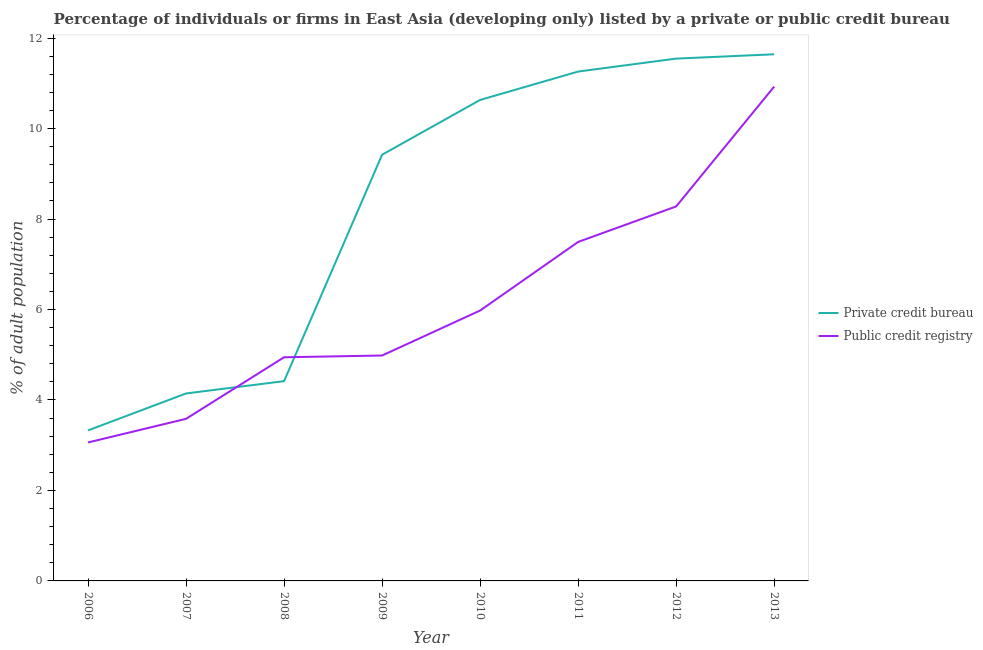Is the number of lines equal to the number of legend labels?
Offer a terse response. Yes. What is the percentage of firms listed by private credit bureau in 2011?
Provide a succinct answer. 11.26. Across all years, what is the maximum percentage of firms listed by public credit bureau?
Your response must be concise. 10.93. Across all years, what is the minimum percentage of firms listed by private credit bureau?
Keep it short and to the point. 3.33. In which year was the percentage of firms listed by private credit bureau minimum?
Your answer should be compact. 2006. What is the total percentage of firms listed by public credit bureau in the graph?
Keep it short and to the point. 49.25. What is the difference between the percentage of firms listed by public credit bureau in 2007 and that in 2008?
Ensure brevity in your answer.  -1.36. What is the difference between the percentage of firms listed by public credit bureau in 2013 and the percentage of firms listed by private credit bureau in 2008?
Keep it short and to the point. 6.51. What is the average percentage of firms listed by private credit bureau per year?
Give a very brief answer. 8.3. In the year 2012, what is the difference between the percentage of firms listed by private credit bureau and percentage of firms listed by public credit bureau?
Your answer should be very brief. 3.27. What is the ratio of the percentage of firms listed by public credit bureau in 2008 to that in 2010?
Give a very brief answer. 0.83. Is the difference between the percentage of firms listed by private credit bureau in 2010 and 2012 greater than the difference between the percentage of firms listed by public credit bureau in 2010 and 2012?
Your response must be concise. Yes. What is the difference between the highest and the second highest percentage of firms listed by public credit bureau?
Make the answer very short. 2.65. What is the difference between the highest and the lowest percentage of firms listed by private credit bureau?
Offer a terse response. 8.32. In how many years, is the percentage of firms listed by private credit bureau greater than the average percentage of firms listed by private credit bureau taken over all years?
Make the answer very short. 5. Does the percentage of firms listed by private credit bureau monotonically increase over the years?
Provide a short and direct response. Yes. Is the percentage of firms listed by public credit bureau strictly greater than the percentage of firms listed by private credit bureau over the years?
Provide a short and direct response. No. Is the percentage of firms listed by public credit bureau strictly less than the percentage of firms listed by private credit bureau over the years?
Ensure brevity in your answer.  No. How many years are there in the graph?
Your answer should be compact. 8. What is the difference between two consecutive major ticks on the Y-axis?
Make the answer very short. 2. Are the values on the major ticks of Y-axis written in scientific E-notation?
Provide a succinct answer. No. Does the graph contain any zero values?
Your answer should be compact. No. Does the graph contain grids?
Your response must be concise. No. How are the legend labels stacked?
Your response must be concise. Vertical. What is the title of the graph?
Keep it short and to the point. Percentage of individuals or firms in East Asia (developing only) listed by a private or public credit bureau. What is the label or title of the X-axis?
Offer a terse response. Year. What is the label or title of the Y-axis?
Your answer should be compact. % of adult population. What is the % of adult population in Private credit bureau in 2006?
Your answer should be very brief. 3.33. What is the % of adult population in Public credit registry in 2006?
Your answer should be compact. 3.06. What is the % of adult population in Private credit bureau in 2007?
Provide a short and direct response. 4.14. What is the % of adult population of Public credit registry in 2007?
Make the answer very short. 3.58. What is the % of adult population of Private credit bureau in 2008?
Your answer should be compact. 4.42. What is the % of adult population in Public credit registry in 2008?
Provide a short and direct response. 4.94. What is the % of adult population of Private credit bureau in 2009?
Your answer should be very brief. 9.42. What is the % of adult population in Public credit registry in 2009?
Keep it short and to the point. 4.98. What is the % of adult population of Private credit bureau in 2010?
Give a very brief answer. 10.63. What is the % of adult population of Public credit registry in 2010?
Give a very brief answer. 5.98. What is the % of adult population in Private credit bureau in 2011?
Your response must be concise. 11.26. What is the % of adult population of Public credit registry in 2011?
Your response must be concise. 7.49. What is the % of adult population of Private credit bureau in 2012?
Keep it short and to the point. 11.55. What is the % of adult population in Public credit registry in 2012?
Provide a succinct answer. 8.28. What is the % of adult population of Private credit bureau in 2013?
Ensure brevity in your answer.  11.64. What is the % of adult population in Public credit registry in 2013?
Keep it short and to the point. 10.93. Across all years, what is the maximum % of adult population of Private credit bureau?
Offer a terse response. 11.64. Across all years, what is the maximum % of adult population of Public credit registry?
Ensure brevity in your answer.  10.93. Across all years, what is the minimum % of adult population in Private credit bureau?
Make the answer very short. 3.33. Across all years, what is the minimum % of adult population of Public credit registry?
Ensure brevity in your answer.  3.06. What is the total % of adult population of Private credit bureau in the graph?
Your answer should be very brief. 66.4. What is the total % of adult population of Public credit registry in the graph?
Provide a succinct answer. 49.25. What is the difference between the % of adult population in Private credit bureau in 2006 and that in 2007?
Give a very brief answer. -0.82. What is the difference between the % of adult population of Public credit registry in 2006 and that in 2007?
Offer a very short reply. -0.52. What is the difference between the % of adult population in Private credit bureau in 2006 and that in 2008?
Provide a succinct answer. -1.09. What is the difference between the % of adult population in Public credit registry in 2006 and that in 2008?
Provide a succinct answer. -1.88. What is the difference between the % of adult population of Private credit bureau in 2006 and that in 2009?
Your answer should be very brief. -6.09. What is the difference between the % of adult population in Public credit registry in 2006 and that in 2009?
Your answer should be compact. -1.92. What is the difference between the % of adult population of Private credit bureau in 2006 and that in 2010?
Your response must be concise. -7.31. What is the difference between the % of adult population of Public credit registry in 2006 and that in 2010?
Provide a succinct answer. -2.92. What is the difference between the % of adult population in Private credit bureau in 2006 and that in 2011?
Give a very brief answer. -7.93. What is the difference between the % of adult population in Public credit registry in 2006 and that in 2011?
Make the answer very short. -4.43. What is the difference between the % of adult population in Private credit bureau in 2006 and that in 2012?
Your answer should be very brief. -8.22. What is the difference between the % of adult population in Public credit registry in 2006 and that in 2012?
Ensure brevity in your answer.  -5.22. What is the difference between the % of adult population of Private credit bureau in 2006 and that in 2013?
Your response must be concise. -8.32. What is the difference between the % of adult population of Public credit registry in 2006 and that in 2013?
Provide a succinct answer. -7.87. What is the difference between the % of adult population of Private credit bureau in 2007 and that in 2008?
Give a very brief answer. -0.27. What is the difference between the % of adult population of Public credit registry in 2007 and that in 2008?
Offer a very short reply. -1.36. What is the difference between the % of adult population in Private credit bureau in 2007 and that in 2009?
Offer a very short reply. -5.28. What is the difference between the % of adult population in Public credit registry in 2007 and that in 2009?
Give a very brief answer. -1.4. What is the difference between the % of adult population of Private credit bureau in 2007 and that in 2010?
Your answer should be very brief. -6.49. What is the difference between the % of adult population of Public credit registry in 2007 and that in 2010?
Provide a succinct answer. -2.39. What is the difference between the % of adult population of Private credit bureau in 2007 and that in 2011?
Your answer should be very brief. -7.12. What is the difference between the % of adult population in Public credit registry in 2007 and that in 2011?
Offer a terse response. -3.91. What is the difference between the % of adult population of Private credit bureau in 2007 and that in 2012?
Your response must be concise. -7.4. What is the difference between the % of adult population of Public credit registry in 2007 and that in 2012?
Ensure brevity in your answer.  -4.7. What is the difference between the % of adult population of Private credit bureau in 2007 and that in 2013?
Provide a succinct answer. -7.5. What is the difference between the % of adult population of Public credit registry in 2007 and that in 2013?
Your answer should be compact. -7.35. What is the difference between the % of adult population in Private credit bureau in 2008 and that in 2009?
Keep it short and to the point. -5.01. What is the difference between the % of adult population of Public credit registry in 2008 and that in 2009?
Your answer should be compact. -0.04. What is the difference between the % of adult population of Private credit bureau in 2008 and that in 2010?
Your response must be concise. -6.22. What is the difference between the % of adult population of Public credit registry in 2008 and that in 2010?
Keep it short and to the point. -1.03. What is the difference between the % of adult population in Private credit bureau in 2008 and that in 2011?
Make the answer very short. -6.84. What is the difference between the % of adult population of Public credit registry in 2008 and that in 2011?
Provide a succinct answer. -2.55. What is the difference between the % of adult population of Private credit bureau in 2008 and that in 2012?
Make the answer very short. -7.13. What is the difference between the % of adult population of Public credit registry in 2008 and that in 2012?
Give a very brief answer. -3.33. What is the difference between the % of adult population of Private credit bureau in 2008 and that in 2013?
Your answer should be very brief. -7.23. What is the difference between the % of adult population in Public credit registry in 2008 and that in 2013?
Keep it short and to the point. -5.98. What is the difference between the % of adult population of Private credit bureau in 2009 and that in 2010?
Provide a succinct answer. -1.21. What is the difference between the % of adult population of Public credit registry in 2009 and that in 2010?
Your answer should be very brief. -0.99. What is the difference between the % of adult population of Private credit bureau in 2009 and that in 2011?
Your response must be concise. -1.84. What is the difference between the % of adult population in Public credit registry in 2009 and that in 2011?
Provide a short and direct response. -2.51. What is the difference between the % of adult population of Private credit bureau in 2009 and that in 2012?
Offer a very short reply. -2.13. What is the difference between the % of adult population of Public credit registry in 2009 and that in 2012?
Keep it short and to the point. -3.3. What is the difference between the % of adult population of Private credit bureau in 2009 and that in 2013?
Ensure brevity in your answer.  -2.22. What is the difference between the % of adult population of Public credit registry in 2009 and that in 2013?
Your answer should be compact. -5.95. What is the difference between the % of adult population of Private credit bureau in 2010 and that in 2011?
Give a very brief answer. -0.63. What is the difference between the % of adult population in Public credit registry in 2010 and that in 2011?
Offer a very short reply. -1.52. What is the difference between the % of adult population in Private credit bureau in 2010 and that in 2012?
Ensure brevity in your answer.  -0.91. What is the difference between the % of adult population of Public credit registry in 2010 and that in 2012?
Offer a very short reply. -2.3. What is the difference between the % of adult population of Private credit bureau in 2010 and that in 2013?
Provide a short and direct response. -1.01. What is the difference between the % of adult population in Public credit registry in 2010 and that in 2013?
Give a very brief answer. -4.95. What is the difference between the % of adult population of Private credit bureau in 2011 and that in 2012?
Ensure brevity in your answer.  -0.29. What is the difference between the % of adult population of Public credit registry in 2011 and that in 2012?
Provide a short and direct response. -0.78. What is the difference between the % of adult population of Private credit bureau in 2011 and that in 2013?
Give a very brief answer. -0.38. What is the difference between the % of adult population in Public credit registry in 2011 and that in 2013?
Make the answer very short. -3.43. What is the difference between the % of adult population of Private credit bureau in 2012 and that in 2013?
Your answer should be very brief. -0.1. What is the difference between the % of adult population of Public credit registry in 2012 and that in 2013?
Keep it short and to the point. -2.65. What is the difference between the % of adult population of Private credit bureau in 2006 and the % of adult population of Public credit registry in 2007?
Make the answer very short. -0.26. What is the difference between the % of adult population in Private credit bureau in 2006 and the % of adult population in Public credit registry in 2008?
Ensure brevity in your answer.  -1.62. What is the difference between the % of adult population in Private credit bureau in 2006 and the % of adult population in Public credit registry in 2009?
Your answer should be very brief. -1.66. What is the difference between the % of adult population in Private credit bureau in 2006 and the % of adult population in Public credit registry in 2010?
Your response must be concise. -2.65. What is the difference between the % of adult population of Private credit bureau in 2006 and the % of adult population of Public credit registry in 2011?
Offer a terse response. -4.17. What is the difference between the % of adult population of Private credit bureau in 2006 and the % of adult population of Public credit registry in 2012?
Your response must be concise. -4.95. What is the difference between the % of adult population in Private credit bureau in 2006 and the % of adult population in Public credit registry in 2013?
Offer a very short reply. -7.6. What is the difference between the % of adult population in Private credit bureau in 2007 and the % of adult population in Public credit registry in 2009?
Your answer should be very brief. -0.84. What is the difference between the % of adult population of Private credit bureau in 2007 and the % of adult population of Public credit registry in 2010?
Provide a succinct answer. -1.83. What is the difference between the % of adult population of Private credit bureau in 2007 and the % of adult population of Public credit registry in 2011?
Give a very brief answer. -3.35. What is the difference between the % of adult population in Private credit bureau in 2007 and the % of adult population in Public credit registry in 2012?
Keep it short and to the point. -4.13. What is the difference between the % of adult population in Private credit bureau in 2007 and the % of adult population in Public credit registry in 2013?
Offer a terse response. -6.78. What is the difference between the % of adult population of Private credit bureau in 2008 and the % of adult population of Public credit registry in 2009?
Make the answer very short. -0.57. What is the difference between the % of adult population of Private credit bureau in 2008 and the % of adult population of Public credit registry in 2010?
Keep it short and to the point. -1.56. What is the difference between the % of adult population in Private credit bureau in 2008 and the % of adult population in Public credit registry in 2011?
Provide a short and direct response. -3.08. What is the difference between the % of adult population of Private credit bureau in 2008 and the % of adult population of Public credit registry in 2012?
Your response must be concise. -3.86. What is the difference between the % of adult population in Private credit bureau in 2008 and the % of adult population in Public credit registry in 2013?
Provide a short and direct response. -6.51. What is the difference between the % of adult population in Private credit bureau in 2009 and the % of adult population in Public credit registry in 2010?
Provide a short and direct response. 3.44. What is the difference between the % of adult population of Private credit bureau in 2009 and the % of adult population of Public credit registry in 2011?
Keep it short and to the point. 1.93. What is the difference between the % of adult population of Private credit bureau in 2009 and the % of adult population of Public credit registry in 2012?
Your response must be concise. 1.14. What is the difference between the % of adult population in Private credit bureau in 2009 and the % of adult population in Public credit registry in 2013?
Your answer should be compact. -1.51. What is the difference between the % of adult population of Private credit bureau in 2010 and the % of adult population of Public credit registry in 2011?
Your response must be concise. 3.14. What is the difference between the % of adult population of Private credit bureau in 2010 and the % of adult population of Public credit registry in 2012?
Give a very brief answer. 2.35. What is the difference between the % of adult population in Private credit bureau in 2010 and the % of adult population in Public credit registry in 2013?
Provide a short and direct response. -0.3. What is the difference between the % of adult population of Private credit bureau in 2011 and the % of adult population of Public credit registry in 2012?
Make the answer very short. 2.98. What is the difference between the % of adult population in Private credit bureau in 2011 and the % of adult population in Public credit registry in 2013?
Make the answer very short. 0.33. What is the difference between the % of adult population in Private credit bureau in 2012 and the % of adult population in Public credit registry in 2013?
Keep it short and to the point. 0.62. What is the average % of adult population in Private credit bureau per year?
Give a very brief answer. 8.3. What is the average % of adult population in Public credit registry per year?
Give a very brief answer. 6.16. In the year 2006, what is the difference between the % of adult population in Private credit bureau and % of adult population in Public credit registry?
Keep it short and to the point. 0.27. In the year 2007, what is the difference between the % of adult population of Private credit bureau and % of adult population of Public credit registry?
Provide a succinct answer. 0.56. In the year 2008, what is the difference between the % of adult population of Private credit bureau and % of adult population of Public credit registry?
Give a very brief answer. -0.53. In the year 2009, what is the difference between the % of adult population in Private credit bureau and % of adult population in Public credit registry?
Your answer should be compact. 4.44. In the year 2010, what is the difference between the % of adult population in Private credit bureau and % of adult population in Public credit registry?
Ensure brevity in your answer.  4.66. In the year 2011, what is the difference between the % of adult population in Private credit bureau and % of adult population in Public credit registry?
Your answer should be very brief. 3.77. In the year 2012, what is the difference between the % of adult population of Private credit bureau and % of adult population of Public credit registry?
Make the answer very short. 3.27. In the year 2013, what is the difference between the % of adult population in Private credit bureau and % of adult population in Public credit registry?
Provide a succinct answer. 0.71. What is the ratio of the % of adult population of Private credit bureau in 2006 to that in 2007?
Make the answer very short. 0.8. What is the ratio of the % of adult population of Public credit registry in 2006 to that in 2007?
Your answer should be compact. 0.85. What is the ratio of the % of adult population in Private credit bureau in 2006 to that in 2008?
Your answer should be very brief. 0.75. What is the ratio of the % of adult population in Public credit registry in 2006 to that in 2008?
Offer a very short reply. 0.62. What is the ratio of the % of adult population of Private credit bureau in 2006 to that in 2009?
Provide a short and direct response. 0.35. What is the ratio of the % of adult population in Public credit registry in 2006 to that in 2009?
Make the answer very short. 0.61. What is the ratio of the % of adult population of Private credit bureau in 2006 to that in 2010?
Your response must be concise. 0.31. What is the ratio of the % of adult population of Public credit registry in 2006 to that in 2010?
Your answer should be very brief. 0.51. What is the ratio of the % of adult population in Private credit bureau in 2006 to that in 2011?
Keep it short and to the point. 0.3. What is the ratio of the % of adult population in Public credit registry in 2006 to that in 2011?
Your answer should be compact. 0.41. What is the ratio of the % of adult population in Private credit bureau in 2006 to that in 2012?
Provide a short and direct response. 0.29. What is the ratio of the % of adult population in Public credit registry in 2006 to that in 2012?
Your answer should be compact. 0.37. What is the ratio of the % of adult population of Private credit bureau in 2006 to that in 2013?
Your response must be concise. 0.29. What is the ratio of the % of adult population of Public credit registry in 2006 to that in 2013?
Make the answer very short. 0.28. What is the ratio of the % of adult population of Private credit bureau in 2007 to that in 2008?
Offer a very short reply. 0.94. What is the ratio of the % of adult population of Public credit registry in 2007 to that in 2008?
Your answer should be very brief. 0.72. What is the ratio of the % of adult population of Private credit bureau in 2007 to that in 2009?
Your answer should be very brief. 0.44. What is the ratio of the % of adult population in Public credit registry in 2007 to that in 2009?
Provide a succinct answer. 0.72. What is the ratio of the % of adult population in Private credit bureau in 2007 to that in 2010?
Offer a very short reply. 0.39. What is the ratio of the % of adult population of Public credit registry in 2007 to that in 2010?
Your answer should be compact. 0.6. What is the ratio of the % of adult population in Private credit bureau in 2007 to that in 2011?
Offer a terse response. 0.37. What is the ratio of the % of adult population of Public credit registry in 2007 to that in 2011?
Your answer should be very brief. 0.48. What is the ratio of the % of adult population of Private credit bureau in 2007 to that in 2012?
Provide a succinct answer. 0.36. What is the ratio of the % of adult population in Public credit registry in 2007 to that in 2012?
Your answer should be compact. 0.43. What is the ratio of the % of adult population in Private credit bureau in 2007 to that in 2013?
Your response must be concise. 0.36. What is the ratio of the % of adult population in Public credit registry in 2007 to that in 2013?
Provide a succinct answer. 0.33. What is the ratio of the % of adult population in Private credit bureau in 2008 to that in 2009?
Keep it short and to the point. 0.47. What is the ratio of the % of adult population in Public credit registry in 2008 to that in 2009?
Offer a very short reply. 0.99. What is the ratio of the % of adult population of Private credit bureau in 2008 to that in 2010?
Keep it short and to the point. 0.42. What is the ratio of the % of adult population of Public credit registry in 2008 to that in 2010?
Keep it short and to the point. 0.83. What is the ratio of the % of adult population of Private credit bureau in 2008 to that in 2011?
Provide a short and direct response. 0.39. What is the ratio of the % of adult population in Public credit registry in 2008 to that in 2011?
Offer a terse response. 0.66. What is the ratio of the % of adult population of Private credit bureau in 2008 to that in 2012?
Provide a short and direct response. 0.38. What is the ratio of the % of adult population in Public credit registry in 2008 to that in 2012?
Ensure brevity in your answer.  0.6. What is the ratio of the % of adult population of Private credit bureau in 2008 to that in 2013?
Give a very brief answer. 0.38. What is the ratio of the % of adult population of Public credit registry in 2008 to that in 2013?
Provide a succinct answer. 0.45. What is the ratio of the % of adult population of Private credit bureau in 2009 to that in 2010?
Your response must be concise. 0.89. What is the ratio of the % of adult population in Public credit registry in 2009 to that in 2010?
Provide a succinct answer. 0.83. What is the ratio of the % of adult population of Private credit bureau in 2009 to that in 2011?
Provide a short and direct response. 0.84. What is the ratio of the % of adult population in Public credit registry in 2009 to that in 2011?
Give a very brief answer. 0.66. What is the ratio of the % of adult population in Private credit bureau in 2009 to that in 2012?
Provide a short and direct response. 0.82. What is the ratio of the % of adult population of Public credit registry in 2009 to that in 2012?
Provide a short and direct response. 0.6. What is the ratio of the % of adult population of Private credit bureau in 2009 to that in 2013?
Ensure brevity in your answer.  0.81. What is the ratio of the % of adult population in Public credit registry in 2009 to that in 2013?
Make the answer very short. 0.46. What is the ratio of the % of adult population in Private credit bureau in 2010 to that in 2011?
Your answer should be very brief. 0.94. What is the ratio of the % of adult population in Public credit registry in 2010 to that in 2011?
Make the answer very short. 0.8. What is the ratio of the % of adult population in Private credit bureau in 2010 to that in 2012?
Offer a terse response. 0.92. What is the ratio of the % of adult population of Public credit registry in 2010 to that in 2012?
Offer a terse response. 0.72. What is the ratio of the % of adult population in Private credit bureau in 2010 to that in 2013?
Provide a short and direct response. 0.91. What is the ratio of the % of adult population of Public credit registry in 2010 to that in 2013?
Make the answer very short. 0.55. What is the ratio of the % of adult population in Private credit bureau in 2011 to that in 2012?
Provide a short and direct response. 0.98. What is the ratio of the % of adult population in Public credit registry in 2011 to that in 2012?
Offer a terse response. 0.91. What is the ratio of the % of adult population of Private credit bureau in 2011 to that in 2013?
Offer a terse response. 0.97. What is the ratio of the % of adult population of Public credit registry in 2011 to that in 2013?
Make the answer very short. 0.69. What is the ratio of the % of adult population of Private credit bureau in 2012 to that in 2013?
Your response must be concise. 0.99. What is the ratio of the % of adult population of Public credit registry in 2012 to that in 2013?
Your answer should be compact. 0.76. What is the difference between the highest and the second highest % of adult population in Private credit bureau?
Keep it short and to the point. 0.1. What is the difference between the highest and the second highest % of adult population in Public credit registry?
Make the answer very short. 2.65. What is the difference between the highest and the lowest % of adult population of Private credit bureau?
Provide a short and direct response. 8.32. What is the difference between the highest and the lowest % of adult population of Public credit registry?
Your answer should be compact. 7.87. 